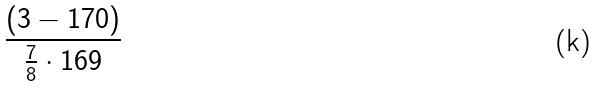Convert formula to latex. <formula><loc_0><loc_0><loc_500><loc_500>\frac { ( 3 - 1 7 0 ) } { \frac { 7 } { 8 } \cdot 1 6 9 }</formula> 